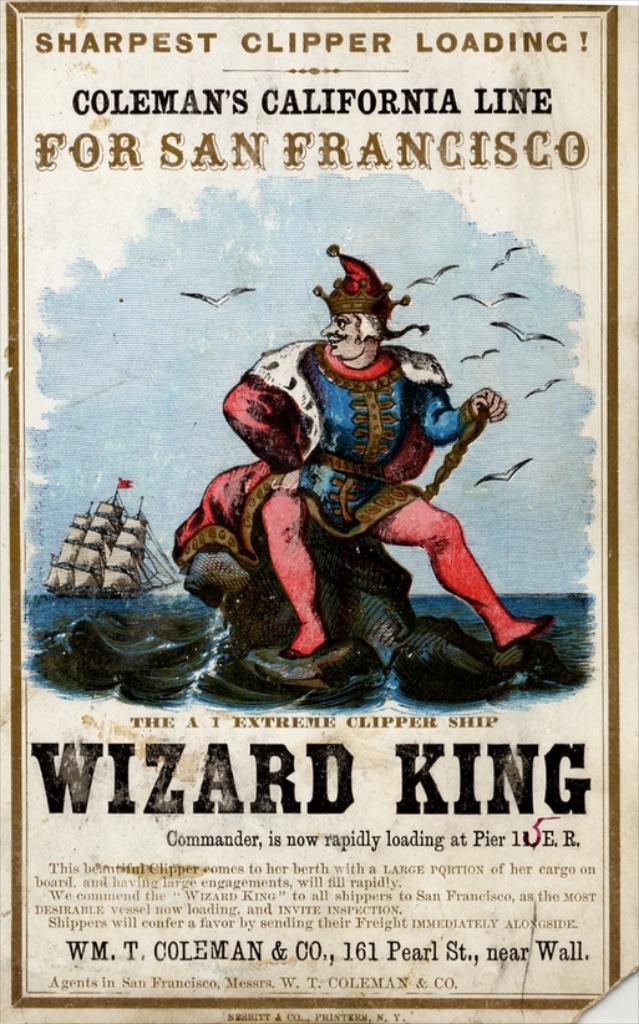Where is this ship going?
Offer a terse response. San francisco. 